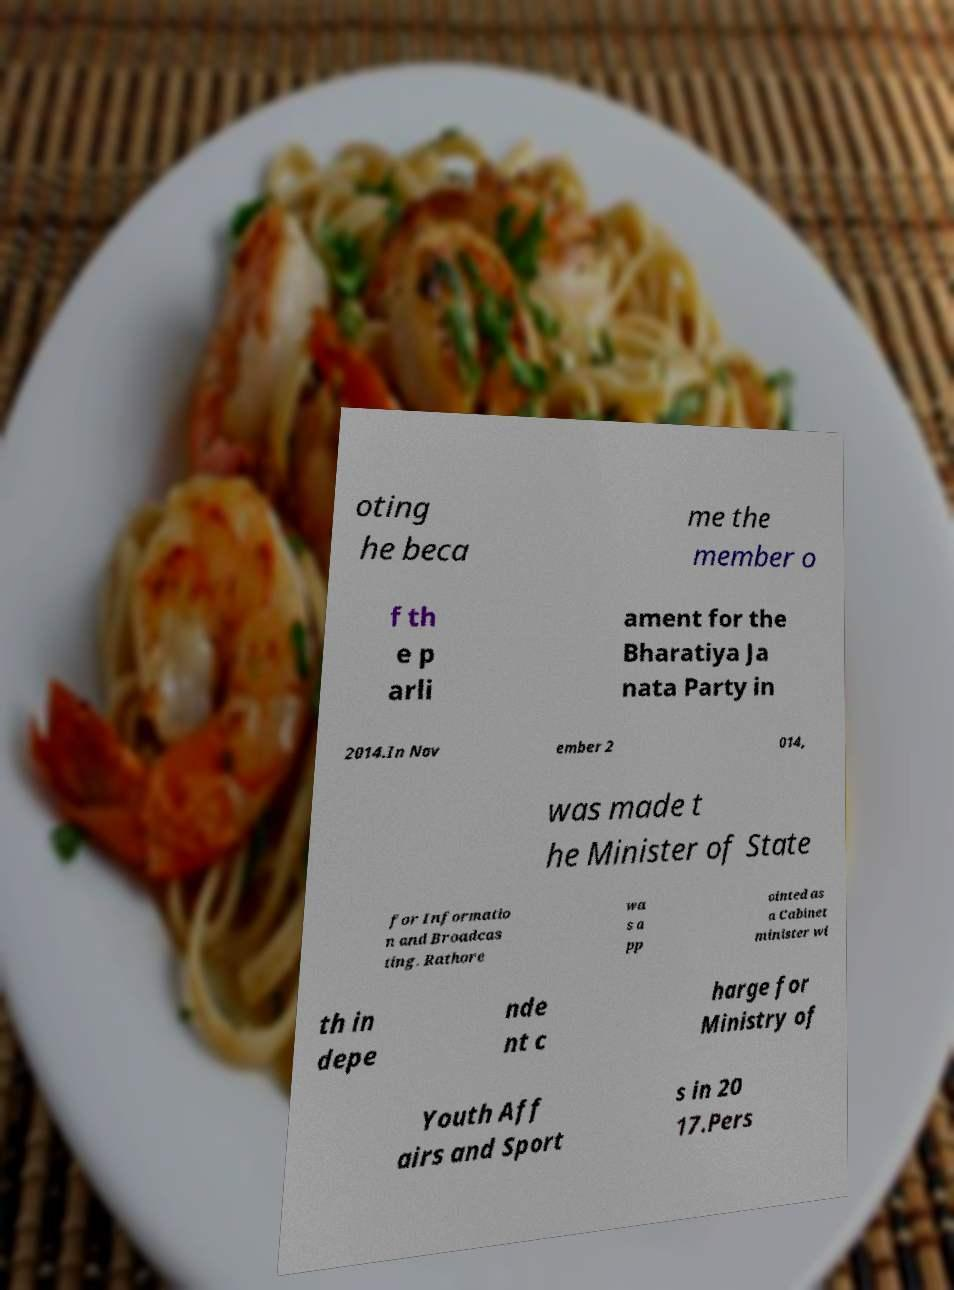Could you assist in decoding the text presented in this image and type it out clearly? oting he beca me the member o f th e p arli ament for the Bharatiya Ja nata Party in 2014.In Nov ember 2 014, was made t he Minister of State for Informatio n and Broadcas ting. Rathore wa s a pp ointed as a Cabinet minister wi th in depe nde nt c harge for Ministry of Youth Aff airs and Sport s in 20 17.Pers 